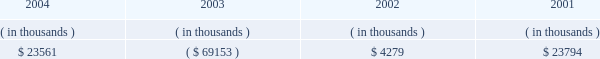Entergy arkansas , inc .
Management's financial discussion and analysis operating activities cash flow from operations increased $ 8.8 million in 2004 compared to 2003 primarily due to income tax benefits received in 2004 , and increased recovery of deferred fuel costs .
This increase was substantially offset by money pool activity .
In 2003 , the domestic utility companies and system energy filed , with the irs , a change in tax accounting method notification for their respective calculations of cost of goods sold .
The adjustment implemented a simplified method of allocation of overhead to the production of electricity , which is provided under the irs capitalization regulations .
The cumulative adjustment placing these companies on the new methodology resulted in a $ 1.171 billion deduction for entergy arkansas on entergy's 2003 income tax return .
There was no cash benefit from the method change in 2003 .
In 2004 , entergy arkansas realized $ 173 million in cash tax benefit from the method change .
This tax accounting method change is an issue across the utility industry and will likely be challenged by the irs on audit .
As of december 31 , 2004 , entergy arkansas has a net operating loss ( nol ) carryforward for tax purposes of $ 766.9 million , principally resulting from the change in tax accounting method related to cost of goods sold .
If the tax accounting method change is sustained , entergy arkansas expects to utilize the nol carryforward through 2006 .
Cash flow from operations increased $ 80.1 million in 2003 compared to 2002 primarily due to income taxes paid of $ 2.2 million in 2003 compared to income taxes paid of $ 83.9 million in 2002 , and money pool activity .
This increase was partially offset by decreased recovery of deferred fuel costs in 2003 .
Entergy arkansas' receivables from or ( payables to ) the money pool were as follows as of december 31 for each of the following years: .
Money pool activity used $ 92.7 million of entergy arkansas' operating cash flow in 2004 , provided $ 73.4 million in 2003 , and provided $ 19.5 million in 2002 .
See note 4 to the domestic utility companies and system energy financial statements for a description of the money pool .
Investing activities the decrease of $ 68.1 million in net cash used in investing activities in 2004 compared to 2003 was primarily due to a decrease in construction expenditures resulting from less transmission upgrade work requested by merchant generators in 2004 combined with lower spending on customer support projects in 2004 .
The increase of $ 88.1 million in net cash used in investing activities in 2003 compared to 2002 was primarily due to an increase in construction expenditures of $ 57.4 million and the maturity of $ 38.4 million of other temporary investments in the first quarter of 2002 .
Construction expenditures increased in 2003 primarily due to the following : 2022 a ferc ruling that shifted responsibility for transmission upgrade work performed for independent power producers to entergy arkansas ; and 2022 the ano 1 steam generator , reactor vessel head , and transformer replacement project .
Financing activities the decrease of $ 90.7 million in net cash used in financing activities in 2004 compared to 2003 was primarily due to the net redemption of $ 2.4 million of long-term debt in 2004 compared to $ 109.3 million in 2003 , partially offset by the payment of $ 16.2 million more in common stock dividends during the same period. .
What portion of the increase in net cash used in investing activities in 2003 is due to an increase in construction expenditures? 
Computations: (57.4 / 88.1)
Answer: 0.65153. 